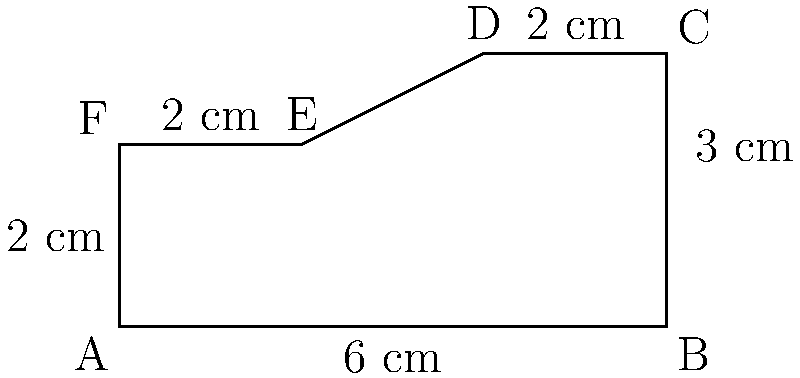A new rifle handguard design has a polygonal cross-section as shown in the diagram. Calculate the total surface area of the handguard if it has a length of 20 cm. How much heat dissipation improvement does this design offer compared to a circular handguard with a diameter of 5 cm and the same length? To solve this problem, we'll follow these steps:

1) Calculate the perimeter of the polygonal cross-section:
   $$P = 6 + 3 + 2 + \sqrt{2^2 + 1^2} + \sqrt{2^2 + 2^2} + 2 = 6 + 3 + 2 + \sqrt{5} + 2\sqrt{2} + 2 \approx 16.65 \text{ cm}$$

2) Calculate the surface area of the polygonal handguard:
   $$A_p = 16.65 \times 20 = 333 \text{ cm}^2$$

3) Calculate the circumference of the circular handguard:
   $$C = \pi d = \pi \times 5 = 15.71 \text{ cm}$$

4) Calculate the surface area of the circular handguard:
   $$A_c = 15.71 \times 20 = 314.2 \text{ cm}^2$$

5) Calculate the improvement in surface area:
   $$\text{Improvement} = \frac{A_p - A_c}{A_c} \times 100\% = \frac{333 - 314.2}{314.2} \times 100\% \approx 6\%$$

The polygonal design offers approximately 6% more surface area for heat dissipation compared to the circular design.
Answer: 333 cm²; 6% improvement 